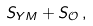Convert formula to latex. <formula><loc_0><loc_0><loc_500><loc_500>S _ { Y M } + S _ { \mathcal { O } } \, ,</formula> 